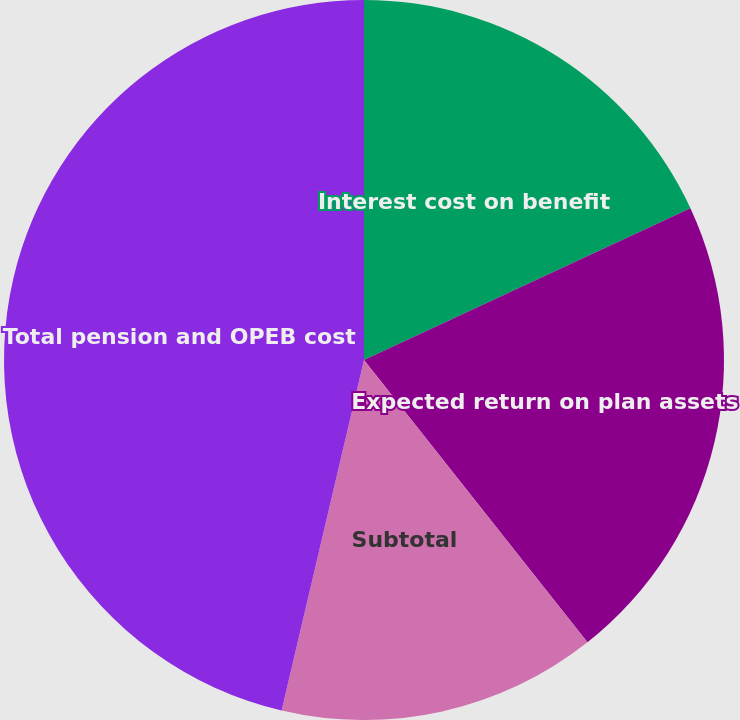<chart> <loc_0><loc_0><loc_500><loc_500><pie_chart><fcel>Interest cost on benefit<fcel>Expected return on plan assets<fcel>Subtotal<fcel>Total pension and OPEB cost<nl><fcel>18.07%<fcel>21.27%<fcel>14.33%<fcel>46.32%<nl></chart> 